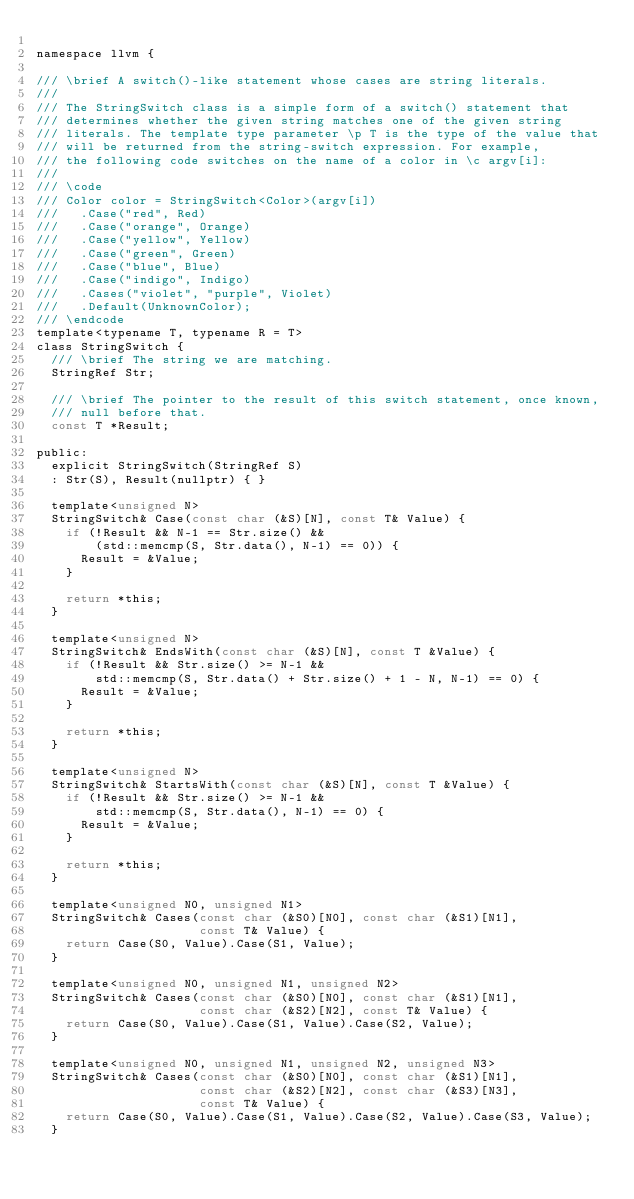Convert code to text. <code><loc_0><loc_0><loc_500><loc_500><_C_>
namespace llvm {

/// \brief A switch()-like statement whose cases are string literals.
///
/// The StringSwitch class is a simple form of a switch() statement that
/// determines whether the given string matches one of the given string
/// literals. The template type parameter \p T is the type of the value that
/// will be returned from the string-switch expression. For example,
/// the following code switches on the name of a color in \c argv[i]:
///
/// \code
/// Color color = StringSwitch<Color>(argv[i])
///   .Case("red", Red)
///   .Case("orange", Orange)
///   .Case("yellow", Yellow)
///   .Case("green", Green)
///   .Case("blue", Blue)
///   .Case("indigo", Indigo)
///   .Cases("violet", "purple", Violet)
///   .Default(UnknownColor);
/// \endcode
template<typename T, typename R = T>
class StringSwitch {
  /// \brief The string we are matching.
  StringRef Str;

  /// \brief The pointer to the result of this switch statement, once known,
  /// null before that.
  const T *Result;

public:
  explicit StringSwitch(StringRef S)
  : Str(S), Result(nullptr) { }

  template<unsigned N>
  StringSwitch& Case(const char (&S)[N], const T& Value) {
    if (!Result && N-1 == Str.size() &&
        (std::memcmp(S, Str.data(), N-1) == 0)) {
      Result = &Value;
    }

    return *this;
  }

  template<unsigned N>
  StringSwitch& EndsWith(const char (&S)[N], const T &Value) {
    if (!Result && Str.size() >= N-1 &&
        std::memcmp(S, Str.data() + Str.size() + 1 - N, N-1) == 0) {
      Result = &Value;
    }

    return *this;
  }

  template<unsigned N>
  StringSwitch& StartsWith(const char (&S)[N], const T &Value) {
    if (!Result && Str.size() >= N-1 &&
        std::memcmp(S, Str.data(), N-1) == 0) {
      Result = &Value;
    }

    return *this;
  }

  template<unsigned N0, unsigned N1>
  StringSwitch& Cases(const char (&S0)[N0], const char (&S1)[N1],
                      const T& Value) {
    return Case(S0, Value).Case(S1, Value);
  }

  template<unsigned N0, unsigned N1, unsigned N2>
  StringSwitch& Cases(const char (&S0)[N0], const char (&S1)[N1],
                      const char (&S2)[N2], const T& Value) {
    return Case(S0, Value).Case(S1, Value).Case(S2, Value);
  }

  template<unsigned N0, unsigned N1, unsigned N2, unsigned N3>
  StringSwitch& Cases(const char (&S0)[N0], const char (&S1)[N1],
                      const char (&S2)[N2], const char (&S3)[N3],
                      const T& Value) {
    return Case(S0, Value).Case(S1, Value).Case(S2, Value).Case(S3, Value);
  }
</code> 